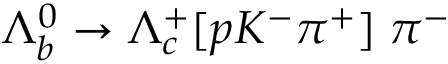<formula> <loc_0><loc_0><loc_500><loc_500>\Lambda _ { b } ^ { 0 } \to \Lambda _ { c } ^ { + } [ p K ^ { - } \pi ^ { + } ] \, \pi ^ { - }</formula> 